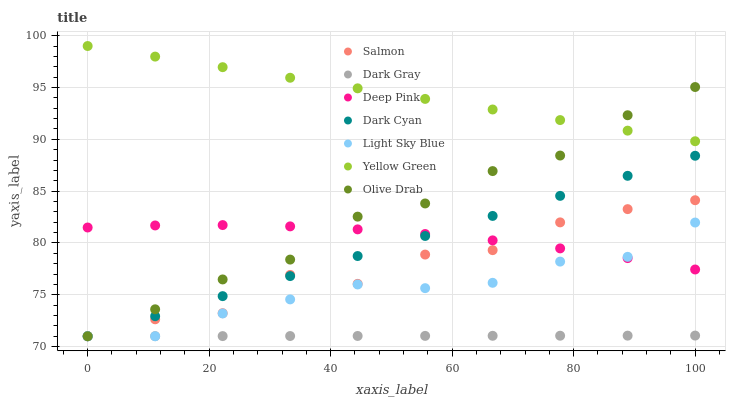Does Dark Gray have the minimum area under the curve?
Answer yes or no. Yes. Does Yellow Green have the maximum area under the curve?
Answer yes or no. Yes. Does Salmon have the minimum area under the curve?
Answer yes or no. No. Does Salmon have the maximum area under the curve?
Answer yes or no. No. Is Yellow Green the smoothest?
Answer yes or no. Yes. Is Salmon the roughest?
Answer yes or no. Yes. Is Salmon the smoothest?
Answer yes or no. No. Is Yellow Green the roughest?
Answer yes or no. No. Does Salmon have the lowest value?
Answer yes or no. Yes. Does Yellow Green have the lowest value?
Answer yes or no. No. Does Yellow Green have the highest value?
Answer yes or no. Yes. Does Salmon have the highest value?
Answer yes or no. No. Is Deep Pink less than Yellow Green?
Answer yes or no. Yes. Is Yellow Green greater than Dark Gray?
Answer yes or no. Yes. Does Dark Cyan intersect Deep Pink?
Answer yes or no. Yes. Is Dark Cyan less than Deep Pink?
Answer yes or no. No. Is Dark Cyan greater than Deep Pink?
Answer yes or no. No. Does Deep Pink intersect Yellow Green?
Answer yes or no. No. 